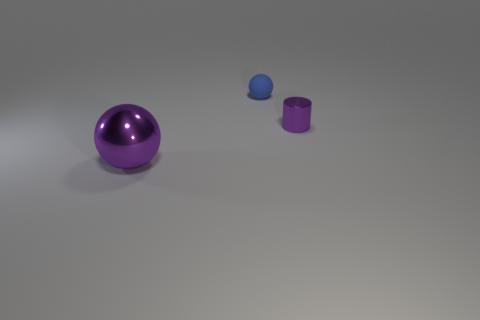Can you describe the lighting in the scene? The lighting in the scene seems to be ambient and diffused, with soft shadows indicating a gentle light source, possibly from above, creating a calm and evenly lit environment. 